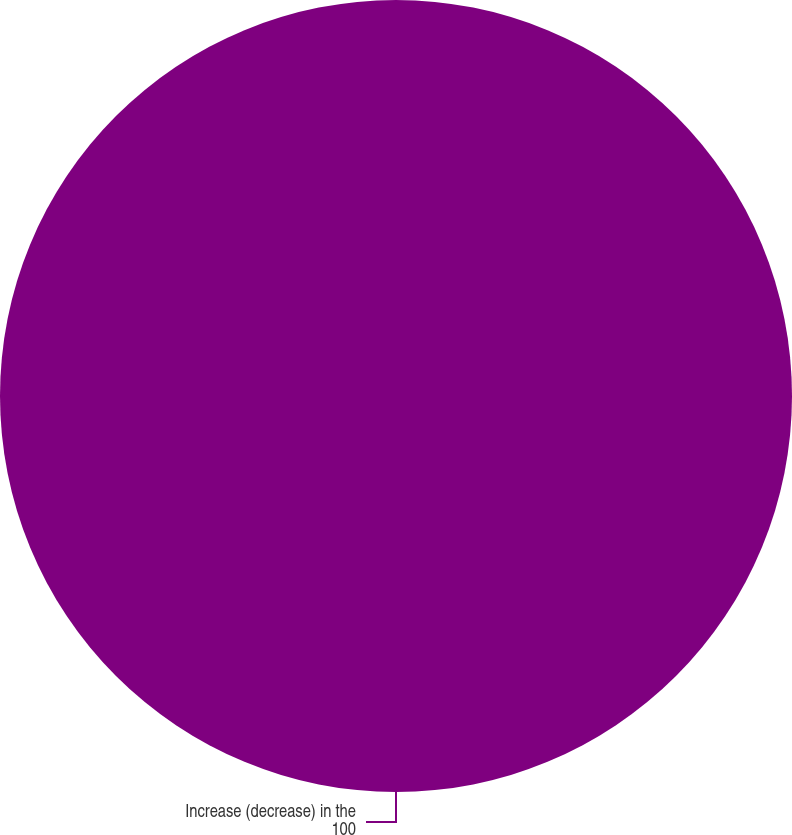<chart> <loc_0><loc_0><loc_500><loc_500><pie_chart><fcel>Increase (decrease) in the<nl><fcel>100.0%<nl></chart> 